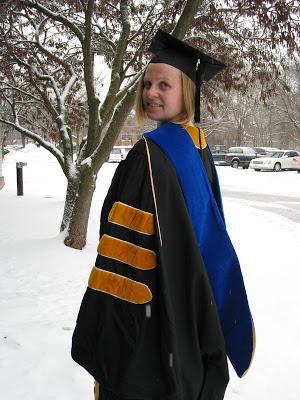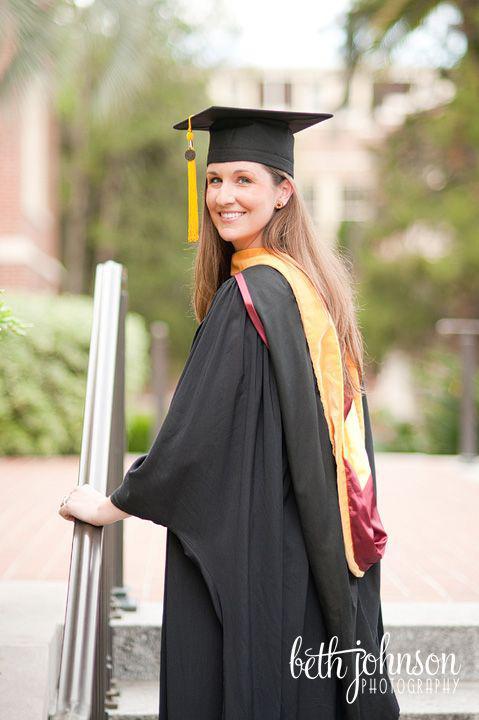The first image is the image on the left, the second image is the image on the right. Analyze the images presented: Is the assertion "In one of the images, there is only one person, and they are facing away from the camera." valid? Answer yes or no. No. The first image is the image on the left, the second image is the image on the right. Evaluate the accuracy of this statement regarding the images: "The graduate in the left image can be seen smiling.". Is it true? Answer yes or no. Yes. 